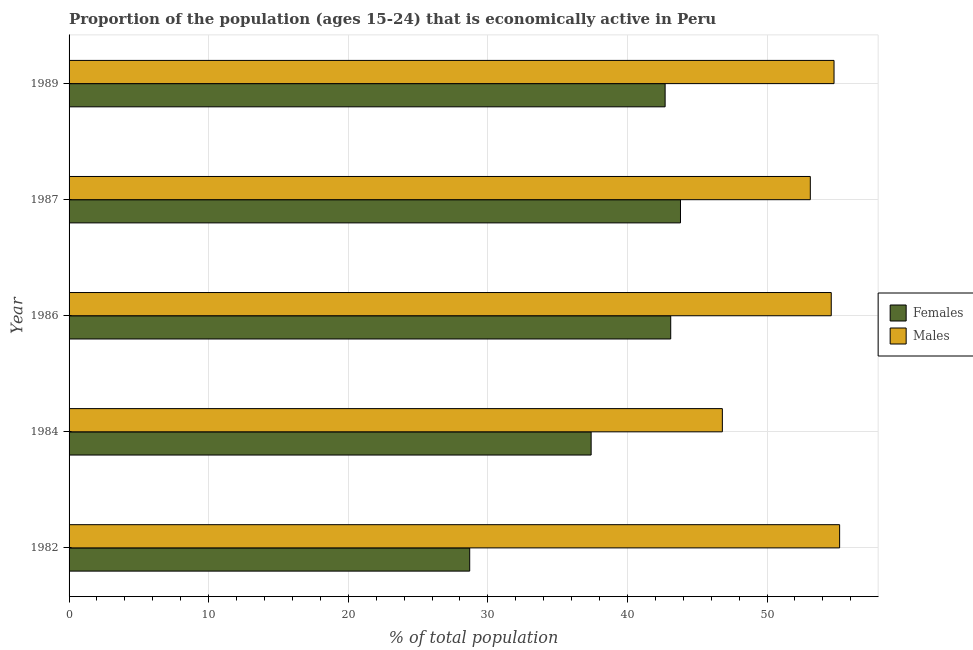How many groups of bars are there?
Give a very brief answer. 5. Are the number of bars per tick equal to the number of legend labels?
Provide a succinct answer. Yes. Are the number of bars on each tick of the Y-axis equal?
Provide a short and direct response. Yes. How many bars are there on the 5th tick from the top?
Offer a very short reply. 2. How many bars are there on the 1st tick from the bottom?
Provide a succinct answer. 2. In how many cases, is the number of bars for a given year not equal to the number of legend labels?
Your response must be concise. 0. What is the percentage of economically active female population in 1986?
Keep it short and to the point. 43.1. Across all years, what is the maximum percentage of economically active male population?
Your answer should be very brief. 55.2. Across all years, what is the minimum percentage of economically active male population?
Offer a terse response. 46.8. In which year was the percentage of economically active female population maximum?
Give a very brief answer. 1987. In which year was the percentage of economically active male population minimum?
Keep it short and to the point. 1984. What is the total percentage of economically active male population in the graph?
Your answer should be compact. 264.5. What is the difference between the percentage of economically active male population in 1986 and the percentage of economically active female population in 1982?
Your answer should be compact. 25.9. What is the average percentage of economically active female population per year?
Offer a very short reply. 39.14. In the year 1982, what is the difference between the percentage of economically active female population and percentage of economically active male population?
Give a very brief answer. -26.5. Is the sum of the percentage of economically active female population in 1987 and 1989 greater than the maximum percentage of economically active male population across all years?
Your answer should be very brief. Yes. What does the 1st bar from the top in 1987 represents?
Your answer should be compact. Males. What does the 2nd bar from the bottom in 1986 represents?
Offer a very short reply. Males. What is the difference between two consecutive major ticks on the X-axis?
Your response must be concise. 10. Does the graph contain any zero values?
Offer a very short reply. No. What is the title of the graph?
Provide a succinct answer. Proportion of the population (ages 15-24) that is economically active in Peru. What is the label or title of the X-axis?
Your answer should be very brief. % of total population. What is the label or title of the Y-axis?
Offer a very short reply. Year. What is the % of total population in Females in 1982?
Give a very brief answer. 28.7. What is the % of total population in Males in 1982?
Your answer should be very brief. 55.2. What is the % of total population of Females in 1984?
Give a very brief answer. 37.4. What is the % of total population in Males in 1984?
Offer a terse response. 46.8. What is the % of total population of Females in 1986?
Make the answer very short. 43.1. What is the % of total population in Males in 1986?
Offer a very short reply. 54.6. What is the % of total population in Females in 1987?
Give a very brief answer. 43.8. What is the % of total population in Males in 1987?
Make the answer very short. 53.1. What is the % of total population in Females in 1989?
Provide a succinct answer. 42.7. What is the % of total population of Males in 1989?
Your answer should be compact. 54.8. Across all years, what is the maximum % of total population of Females?
Offer a terse response. 43.8. Across all years, what is the maximum % of total population in Males?
Your answer should be compact. 55.2. Across all years, what is the minimum % of total population of Females?
Offer a terse response. 28.7. Across all years, what is the minimum % of total population of Males?
Provide a short and direct response. 46.8. What is the total % of total population of Females in the graph?
Keep it short and to the point. 195.7. What is the total % of total population of Males in the graph?
Provide a succinct answer. 264.5. What is the difference between the % of total population in Males in 1982 and that in 1984?
Provide a short and direct response. 8.4. What is the difference between the % of total population of Females in 1982 and that in 1986?
Your answer should be very brief. -14.4. What is the difference between the % of total population in Females in 1982 and that in 1987?
Provide a short and direct response. -15.1. What is the difference between the % of total population of Females in 1984 and that in 1986?
Your response must be concise. -5.7. What is the difference between the % of total population in Males in 1984 and that in 1986?
Offer a very short reply. -7.8. What is the difference between the % of total population in Females in 1984 and that in 1987?
Your answer should be compact. -6.4. What is the difference between the % of total population of Females in 1984 and that in 1989?
Give a very brief answer. -5.3. What is the difference between the % of total population of Males in 1984 and that in 1989?
Your answer should be very brief. -8. What is the difference between the % of total population in Females in 1986 and that in 1987?
Give a very brief answer. -0.7. What is the difference between the % of total population in Males in 1986 and that in 1987?
Provide a short and direct response. 1.5. What is the difference between the % of total population of Females in 1982 and the % of total population of Males in 1984?
Your answer should be very brief. -18.1. What is the difference between the % of total population in Females in 1982 and the % of total population in Males in 1986?
Your answer should be compact. -25.9. What is the difference between the % of total population in Females in 1982 and the % of total population in Males in 1987?
Your answer should be very brief. -24.4. What is the difference between the % of total population in Females in 1982 and the % of total population in Males in 1989?
Keep it short and to the point. -26.1. What is the difference between the % of total population in Females in 1984 and the % of total population in Males in 1986?
Make the answer very short. -17.2. What is the difference between the % of total population in Females in 1984 and the % of total population in Males in 1987?
Your answer should be very brief. -15.7. What is the difference between the % of total population of Females in 1984 and the % of total population of Males in 1989?
Keep it short and to the point. -17.4. What is the difference between the % of total population in Females in 1986 and the % of total population in Males in 1989?
Your response must be concise. -11.7. What is the average % of total population in Females per year?
Offer a very short reply. 39.14. What is the average % of total population in Males per year?
Give a very brief answer. 52.9. In the year 1982, what is the difference between the % of total population of Females and % of total population of Males?
Offer a terse response. -26.5. In the year 1987, what is the difference between the % of total population of Females and % of total population of Males?
Provide a succinct answer. -9.3. In the year 1989, what is the difference between the % of total population of Females and % of total population of Males?
Offer a terse response. -12.1. What is the ratio of the % of total population of Females in 1982 to that in 1984?
Keep it short and to the point. 0.77. What is the ratio of the % of total population in Males in 1982 to that in 1984?
Offer a very short reply. 1.18. What is the ratio of the % of total population in Females in 1982 to that in 1986?
Make the answer very short. 0.67. What is the ratio of the % of total population in Males in 1982 to that in 1986?
Offer a terse response. 1.01. What is the ratio of the % of total population in Females in 1982 to that in 1987?
Ensure brevity in your answer.  0.66. What is the ratio of the % of total population of Males in 1982 to that in 1987?
Your answer should be compact. 1.04. What is the ratio of the % of total population in Females in 1982 to that in 1989?
Offer a very short reply. 0.67. What is the ratio of the % of total population of Males in 1982 to that in 1989?
Your answer should be very brief. 1.01. What is the ratio of the % of total population of Females in 1984 to that in 1986?
Your response must be concise. 0.87. What is the ratio of the % of total population in Males in 1984 to that in 1986?
Your answer should be very brief. 0.86. What is the ratio of the % of total population of Females in 1984 to that in 1987?
Keep it short and to the point. 0.85. What is the ratio of the % of total population of Males in 1984 to that in 1987?
Ensure brevity in your answer.  0.88. What is the ratio of the % of total population of Females in 1984 to that in 1989?
Offer a very short reply. 0.88. What is the ratio of the % of total population in Males in 1984 to that in 1989?
Your answer should be very brief. 0.85. What is the ratio of the % of total population in Males in 1986 to that in 1987?
Keep it short and to the point. 1.03. What is the ratio of the % of total population of Females in 1986 to that in 1989?
Make the answer very short. 1.01. What is the ratio of the % of total population of Females in 1987 to that in 1989?
Give a very brief answer. 1.03. What is the ratio of the % of total population in Males in 1987 to that in 1989?
Offer a very short reply. 0.97. What is the difference between the highest and the lowest % of total population of Females?
Keep it short and to the point. 15.1. What is the difference between the highest and the lowest % of total population in Males?
Your answer should be very brief. 8.4. 